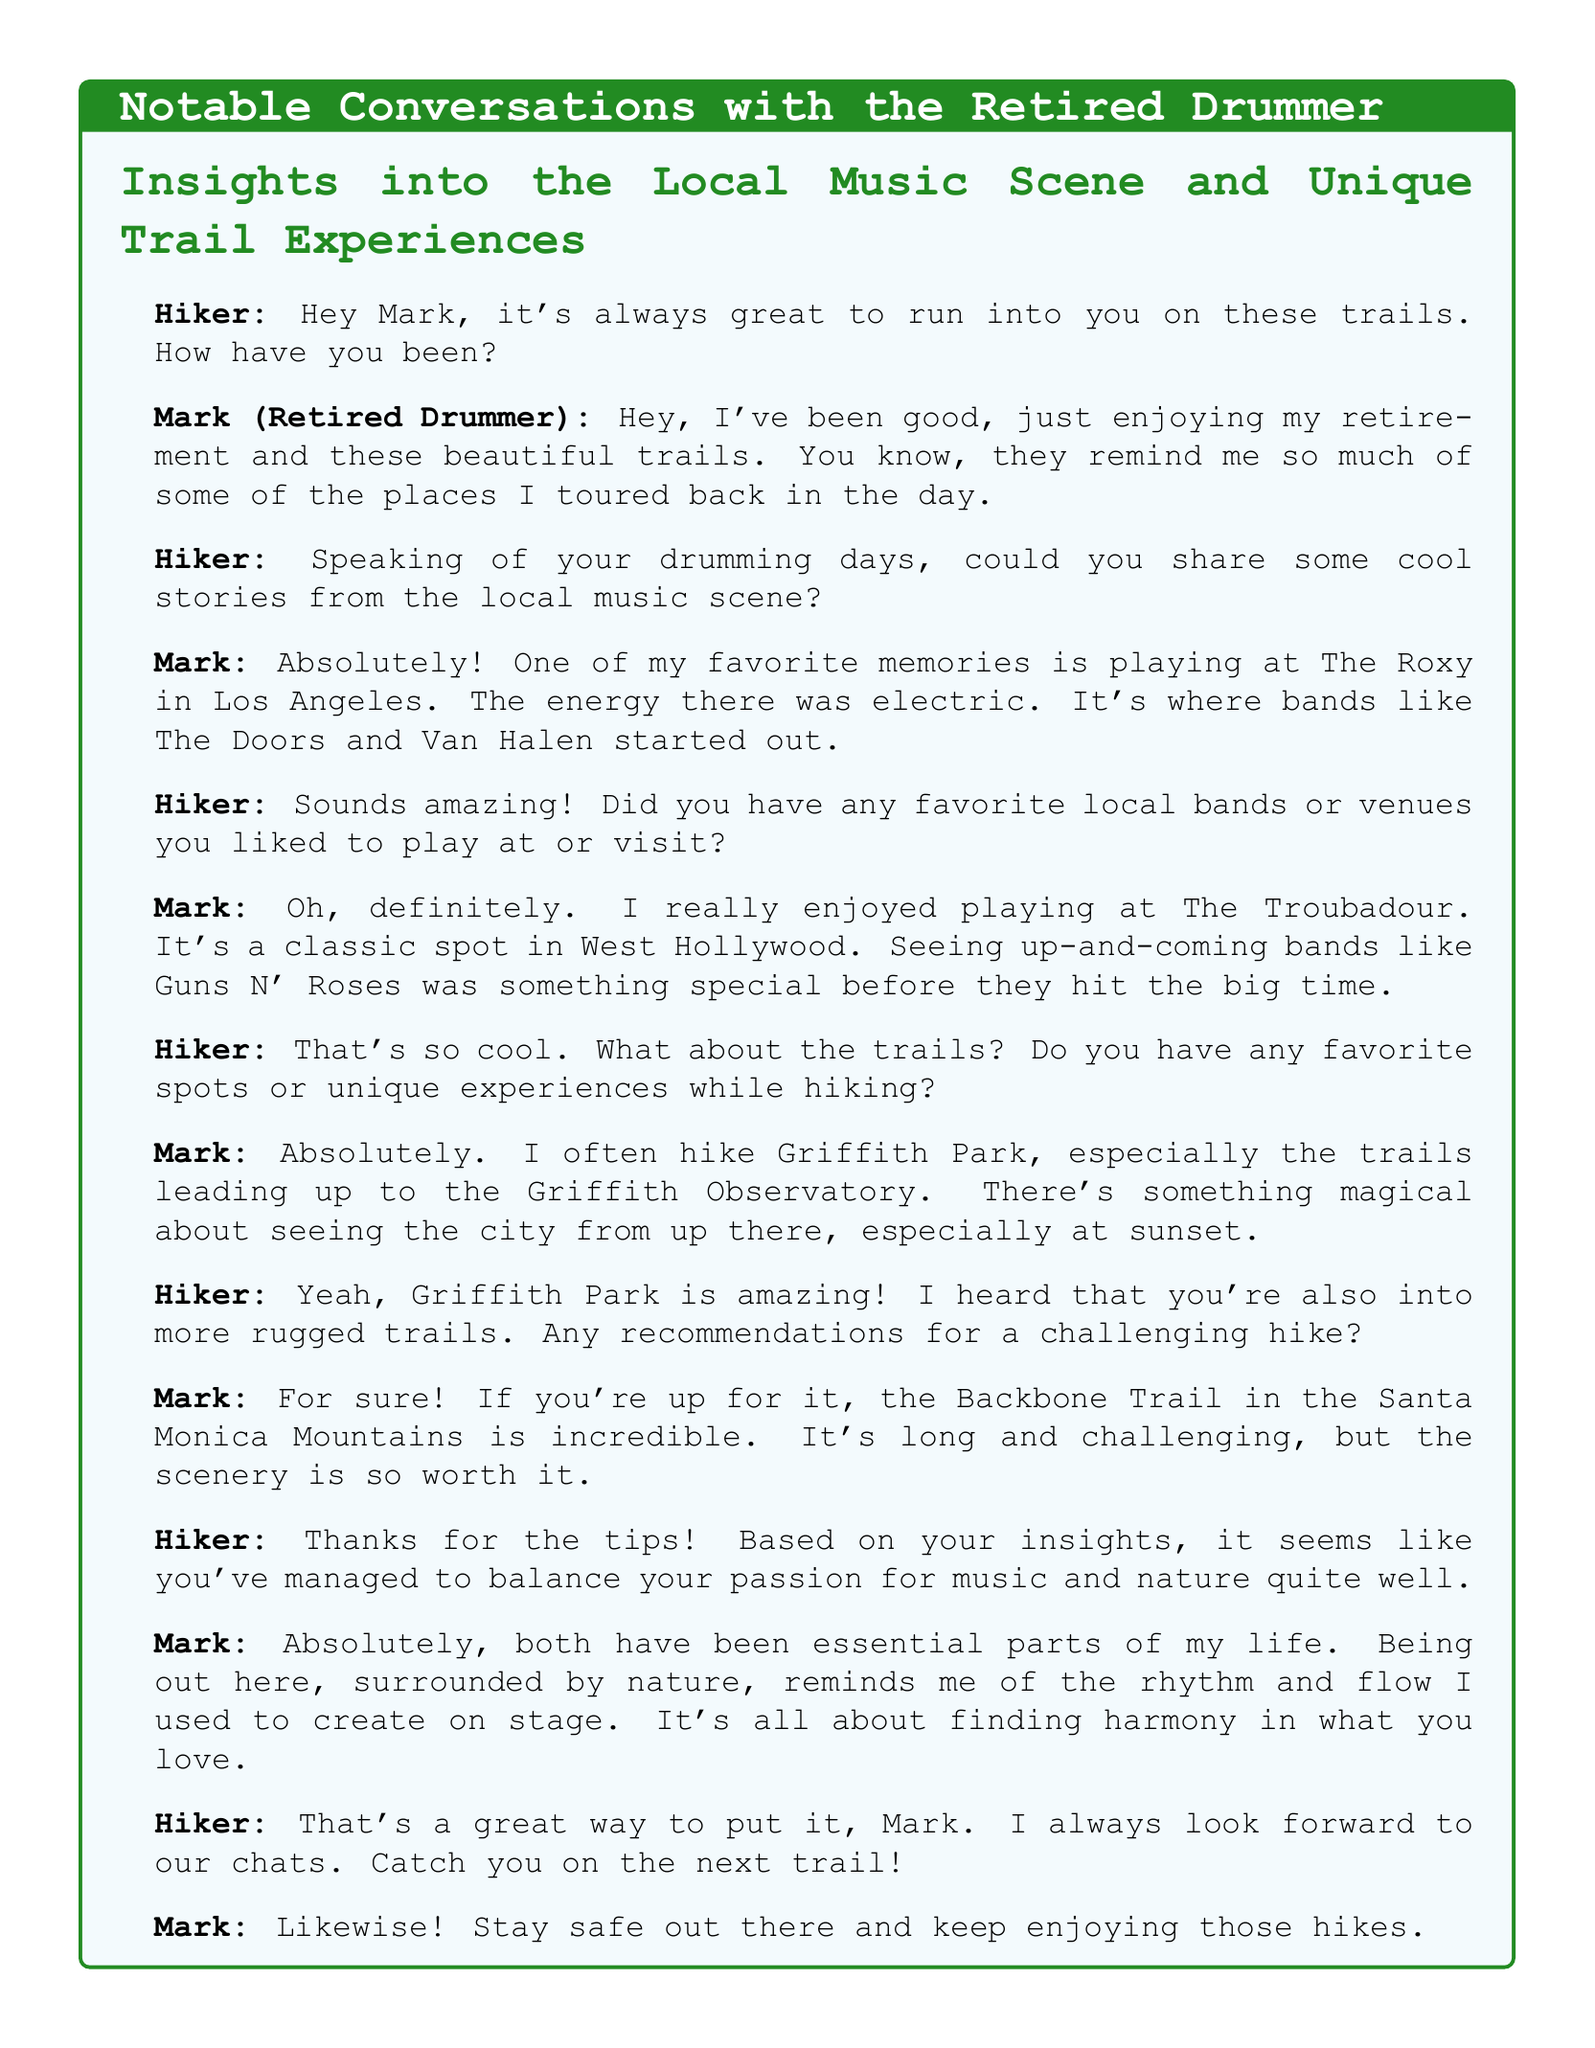What is the retired drummer's name? The document identifies the retired drummer as "Mark."
Answer: Mark What venue did Mark mention playing at in Los Angeles? Mark shared that one of his favorite memories is playing at "The Roxy."
Answer: The Roxy Which classic spot in West Hollywood did Mark enjoy? Mark specifically mentioned enjoying playing at "The Troubadour."
Answer: The Troubadour What trail does Mark often hike that leads to a notable observatory? Mark often hikes trails leading up to the "Griffith Observatory."
Answer: Griffith Observatory What is the challenging hike that Mark recommends? Mark recommends the "Backbone Trail" in the Santa Monica Mountains.
Answer: Backbone Trail What element does Mark associate with being in nature? Mark relates being in nature to the "rhythm and flow" he used to create on stage.
Answer: rhythm and flow How does Mark feel about balancing his passions? Mark believes that both music and nature have been "essential parts" of his life.
Answer: essential parts What does Mark enjoy our chats? Mark expresses that he always looks forward to their conversations about music and hiking.
Answer: chats What time of day does Mark find magical when hiking Griffith Park? Mark finds the view from Griffith Park especially magical at "sunset."
Answer: sunset 